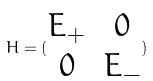Convert formula to latex. <formula><loc_0><loc_0><loc_500><loc_500>H = ( \begin{matrix} E _ { + } & 0 \\ 0 & E _ { - } \end{matrix} )</formula> 